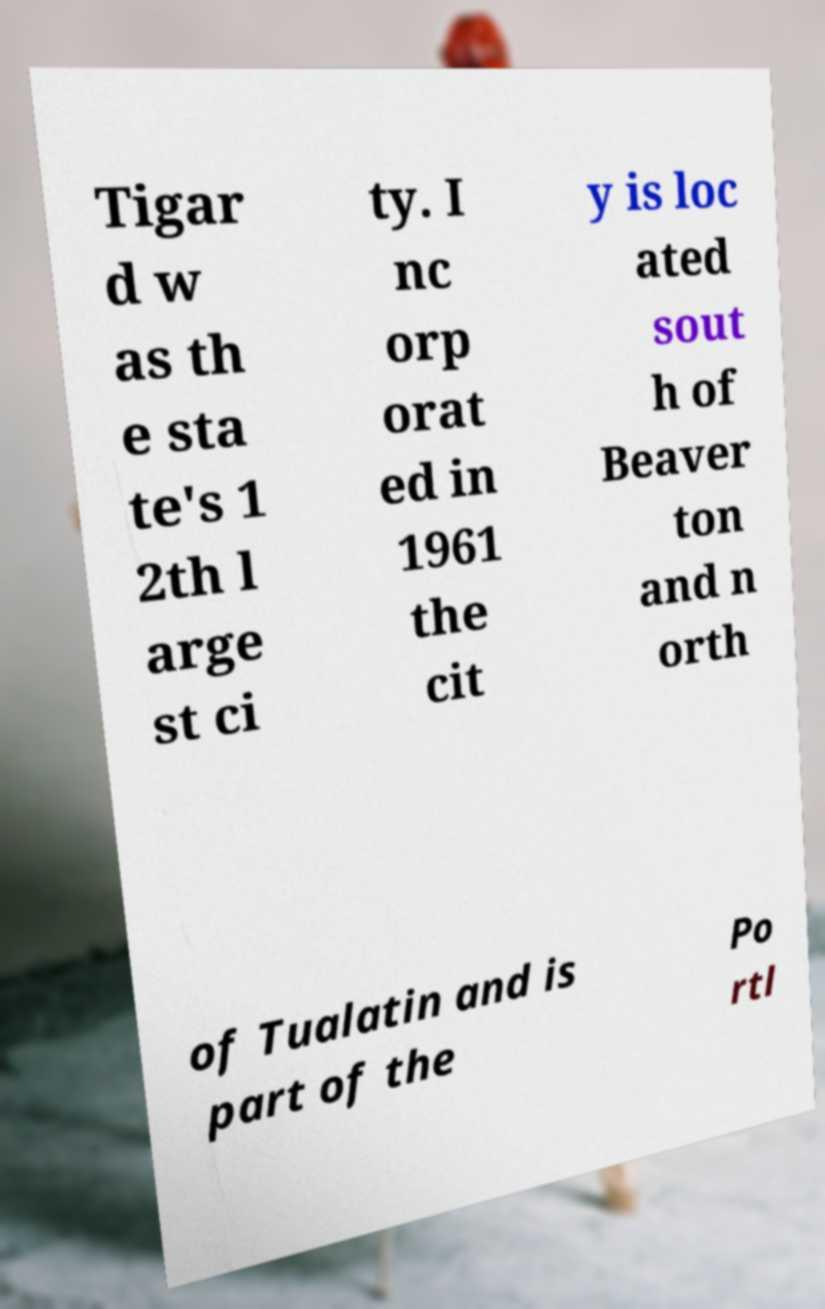Please identify and transcribe the text found in this image. Tigar d w as th e sta te's 1 2th l arge st ci ty. I nc orp orat ed in 1961 the cit y is loc ated sout h of Beaver ton and n orth of Tualatin and is part of the Po rtl 